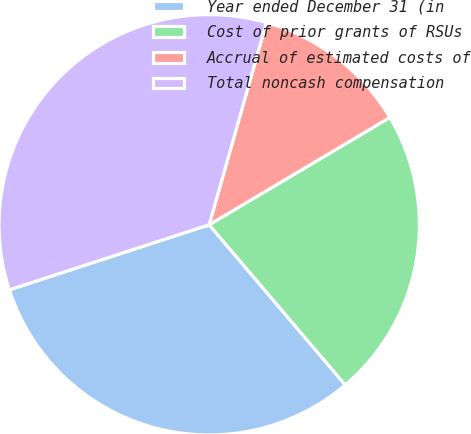Convert chart to OTSL. <chart><loc_0><loc_0><loc_500><loc_500><pie_chart><fcel>Year ended December 31 (in<fcel>Cost of prior grants of RSUs<fcel>Accrual of estimated costs of<fcel>Total noncash compensation<nl><fcel>31.2%<fcel>22.32%<fcel>12.08%<fcel>34.4%<nl></chart> 